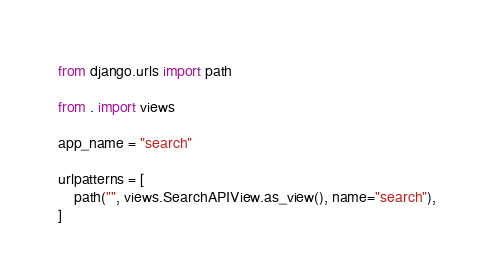Convert code to text. <code><loc_0><loc_0><loc_500><loc_500><_Python_>from django.urls import path

from . import views

app_name = "search"

urlpatterns = [
    path("", views.SearchAPIView.as_view(), name="search"),
]
</code> 